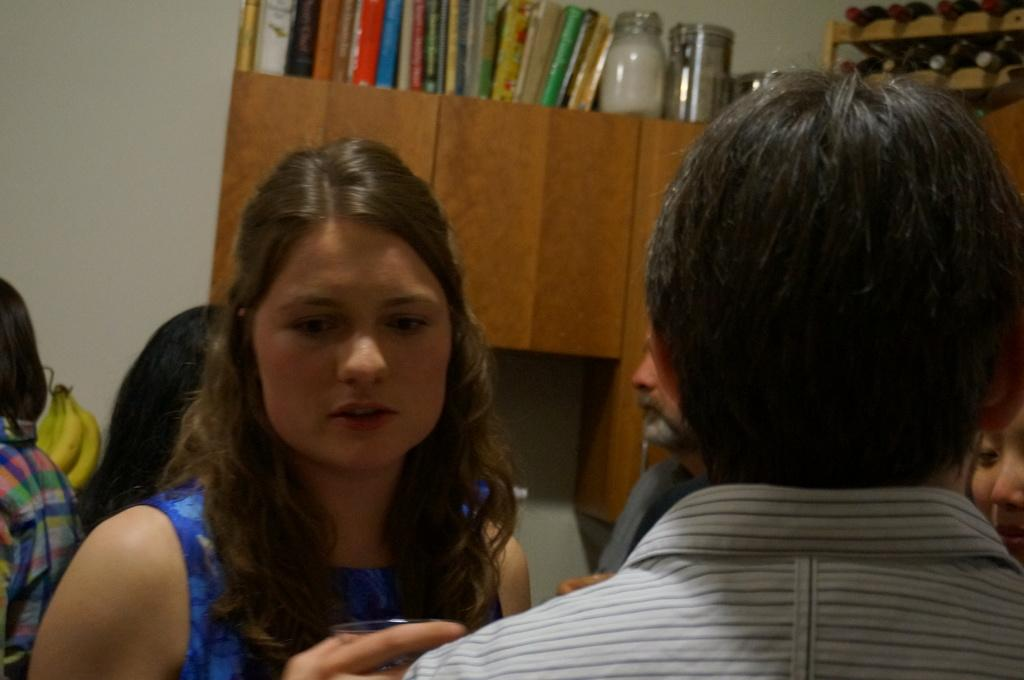<image>
Describe the image concisely. A group of people are mingling at a party in front of a book about Pirates. 